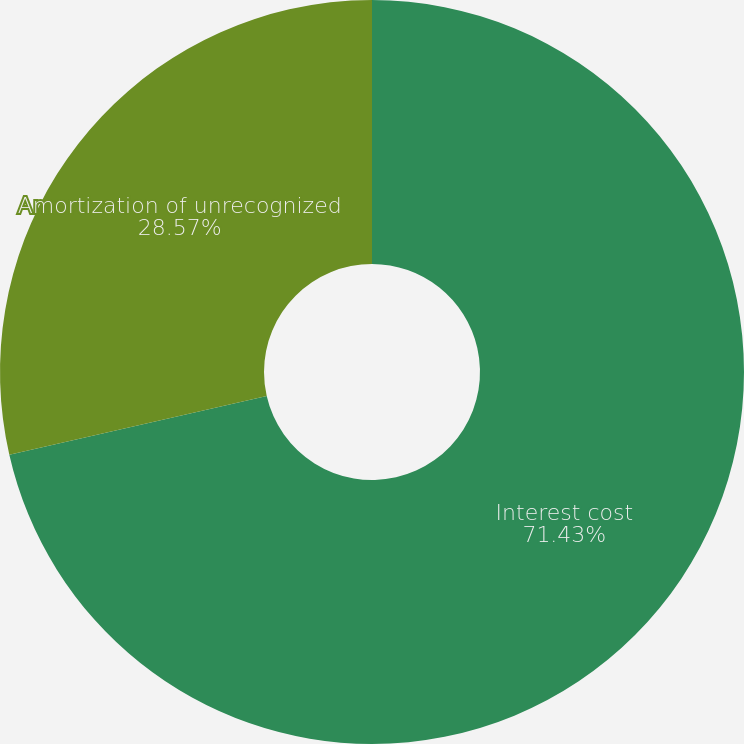<chart> <loc_0><loc_0><loc_500><loc_500><pie_chart><fcel>Interest cost<fcel>Amortization of unrecognized<nl><fcel>71.43%<fcel>28.57%<nl></chart> 